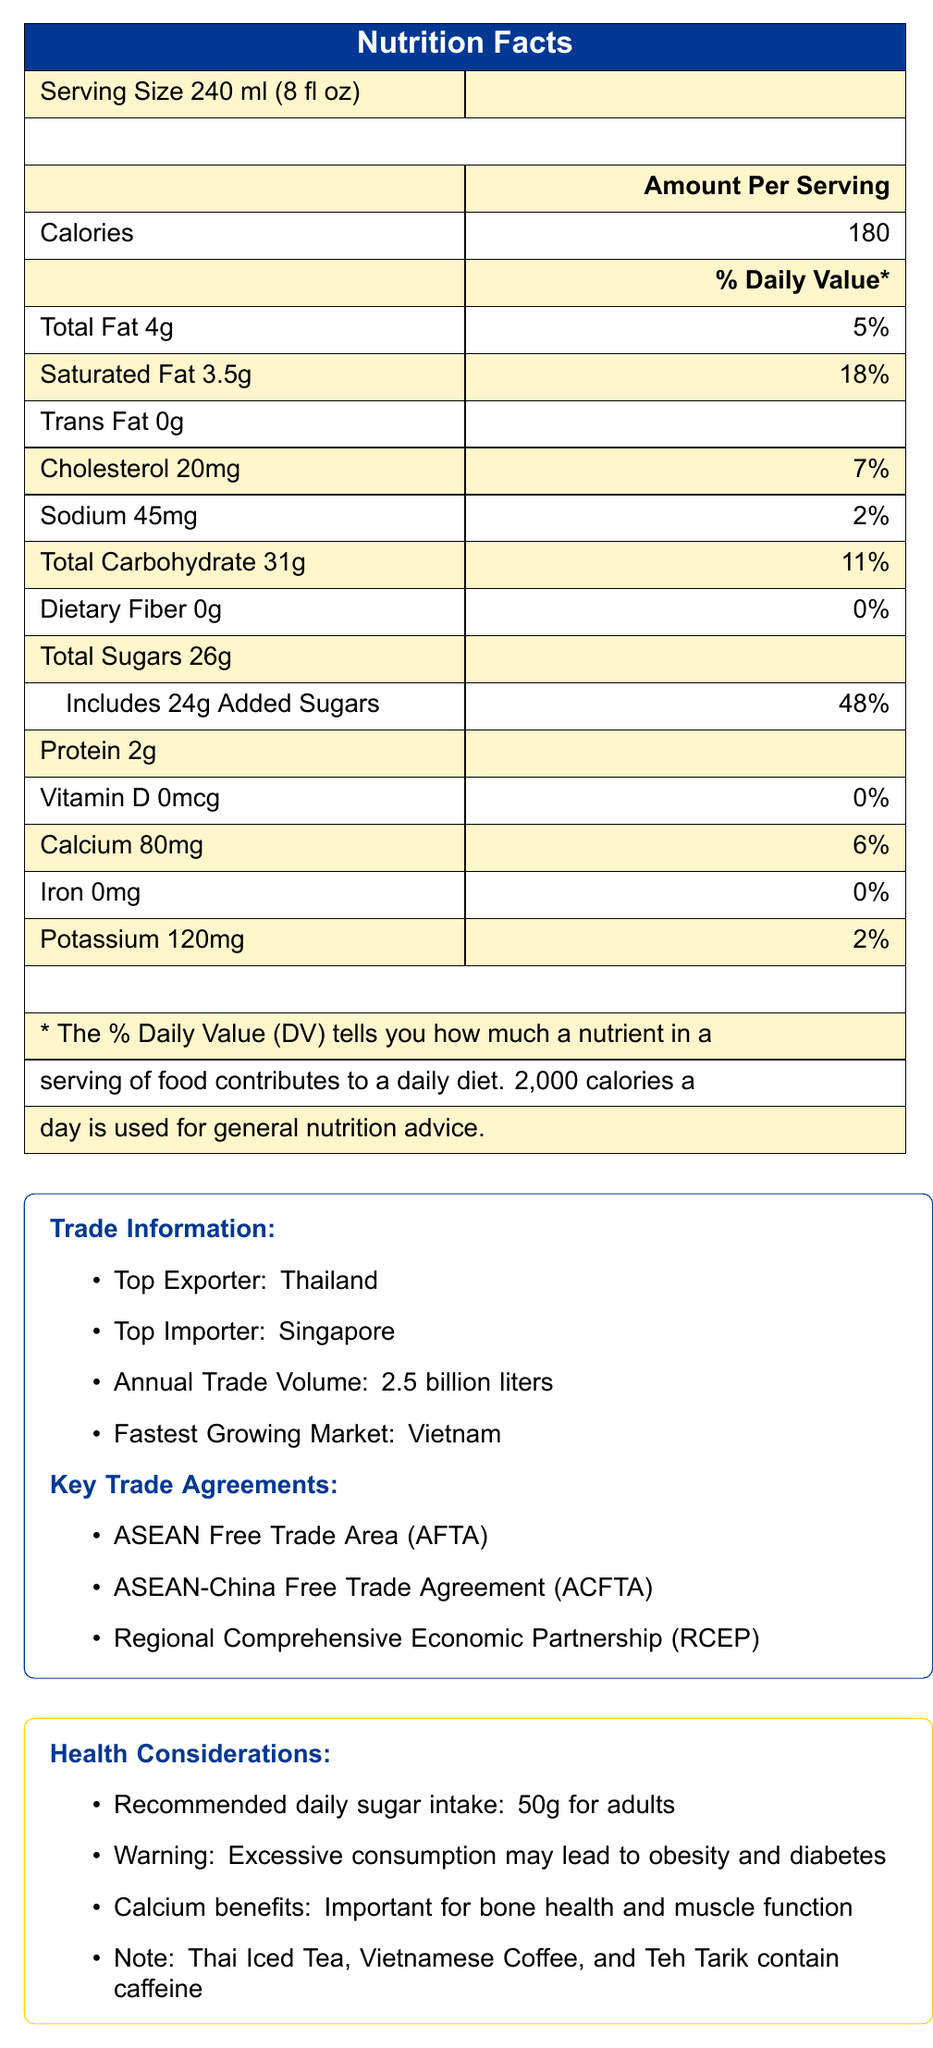what is the recommended daily sugar intake for adults? The document states that the recommended daily sugar intake for adults is 50g.
Answer: 50g which beverage has the highest total sugar content? A. Thai Iced Tea B. Vietnamese Coffee C. Calamansi Juice D. Teh Tarik Thai Iced Tea contains 26g of total sugars, which is the highest among the listed beverages.
Answer: A is Thai Iced Tea higher in calories than Vietnamese Coffee? Thai Iced Tea has 180 calories per serving, while Vietnamese Coffee has 120 calories per serving.
Answer: Yes what is the annual trade volume of beverages in ASEAN countries? The document specifies that the annual trade volume of beverages is 2.5 billion liters.
Answer: 2.5 billion liters which beverage contains the highest amount of calcium? Soya Bean Milk contains 300mg of calcium, which is the highest among the listed beverages.
Answer: Soya Bean Milk order the beverages by their total calorie content from highest to lowest: i. Thai Iced Tea ii. Calamansi Juice iii. Teh Tarik iv. Vietnamese Coffee v. Soya Bean Milk Thai Iced Tea (180), Teh Tarik (150), Vietnamese Coffee (120), Soya Bean Milk (110), Calamansi Juice (90).
Answer: i, iii, iv, v, ii are all the beverages listed containing caffeine? Only Thai Iced Tea, Vietnamese Coffee, and Teh Tarik contain caffeine, as per the health considerations in the document.
Answer: No what percentage of ASEAN GDP does the beverage industry contribute? The document mentions that the beverage industry contributes 3.5% to the ASEAN GDP.
Answer: 3.5% which trade agreement is mentioned in the document related to ASEAN countries? A. NAFTA B. EU Single Market C. ASEAN Free Trade Area (AFTA) D. Mercosur The document lists the ASEAN Free Trade Area (AFTA) as a key trade agreement.
Answer: C which ASEAN country is the fastest-growing market for beverages? The document identifies Vietnam as the fastest-growing market for beverages in ASEAN countries.
Answer: Vietnam what warning is given about high sugar content? The document warns that excessive sugar consumption may lead to obesity and diabetes.
Answer: Excessive consumption may lead to obesity and diabetes by how much is the beverage industry projected to grow annually from 2023 to 2028? The future growth projection for the beverage industry is 5.8% CAGR from 2023 to 2028.
Answer: 5.8% CAGR summarize the main idea of the document in one sentence This includes details about nutritional content, trade volumes, and economic significance of the beverage industry in ASEAN countries.
Answer: The document provides a comparison of calorie and sugar content in popular beverages traded across ASEAN countries, along with trade information, health considerations, and economic impact. what is the total protein content in Vietnamese Coffee and Teh Tarik combined? Vietnamese Coffee has 2g of protein, and Teh Tarik has 2g of protein, making a combined total of 4g.
Answer: 4g which country is the top importer of beverages in ASEAN? The document states that Singapore is the top importer of beverages in ASEAN.
Answer: Singapore is the total carbohydrate content higher in Calamansi Juice than in Soya Bean Milk? Calamansi Juice contains 23g of total carbohydrates, while Soya Bean Milk contains 14g.
Answer: Yes what is the calcium content of Teh Tarik? The document lists the calcium content of Teh Tarik as 100mg.
Answer: 100mg does the document provide information on the fiber content in all the beverages? The document lists the dietary fiber content for each beverage.
Answer: Yes explain the economic impact of the beverage industry in ASEAN countries as described in the document The document outlines that the beverage industry has significant economic contributions in terms of GDP, employment, export revenue, and future growth prospects.
Answer: The beverage industry contributes 3.5% of ASEAN GDP, provides over 500,000 jobs, generates USD 7.2 billion annually in export revenue, and is projected to grow at a CAGR of 5.8% from 2023 to 2028. which countries are explicitly mentioned as the origin of the beverages listed? The document mentions that Thai Iced Tea is from Thailand, Vietnamese Coffee from Vietnam, Calamansi Juice from the Philippines, Teh Tarik from Malaysia, and Soya Bean Milk from Singapore.
Answer: Thailand, Vietnam, Philippines, Malaysia, Singapore 